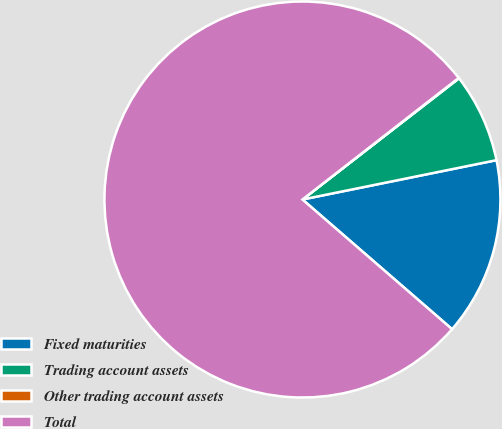<chart> <loc_0><loc_0><loc_500><loc_500><pie_chart><fcel>Fixed maturities<fcel>Trading account assets<fcel>Other trading account assets<fcel>Total<nl><fcel>14.55%<fcel>7.3%<fcel>0.04%<fcel>78.11%<nl></chart> 